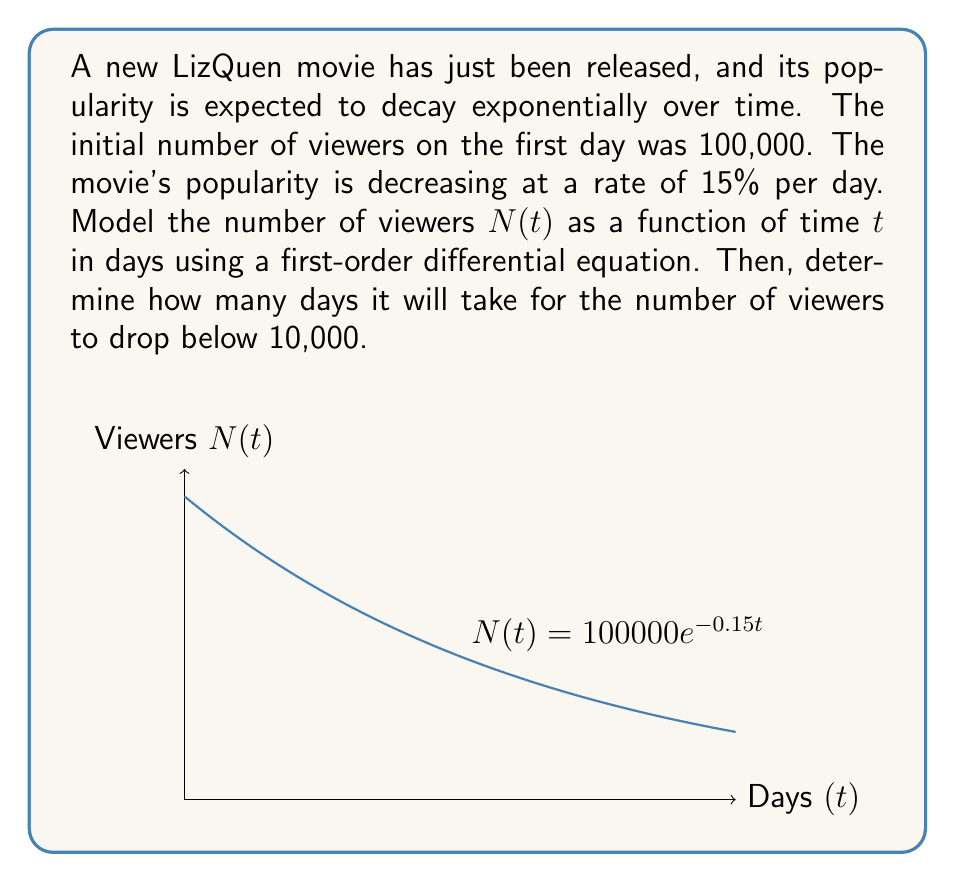Could you help me with this problem? Let's approach this step-by-step:

1) The rate of change of viewers is proportional to the current number of viewers. This can be modeled by the differential equation:

   $$\frac{dN}{dt} = -kN$$

   where $k$ is the decay constant.

2) We're given that the decay rate is 15% per day. This means $k = 0.15$.

3) The initial condition is $N(0) = 100,000$.

4) The solution to this differential equation is:

   $$N(t) = N_0e^{-kt}$$

   where $N_0$ is the initial number of viewers.

5) Substituting our values:

   $$N(t) = 100,000e^{-0.15t}$$

6) To find when the number of viewers drops below 10,000, we solve:

   $$10,000 = 100,000e^{-0.15t}$$

7) Dividing both sides by 100,000:

   $$0.1 = e^{-0.15t}$$

8) Taking the natural log of both sides:

   $$\ln(0.1) = -0.15t$$

9) Solving for $t$:

   $$t = \frac{-\ln(0.1)}{0.15} \approx 15.33$$

Therefore, it will take approximately 15.33 days for the number of viewers to drop below 10,000.
Answer: $N(t) = 100,000e^{-0.15t}$; 15.33 days 